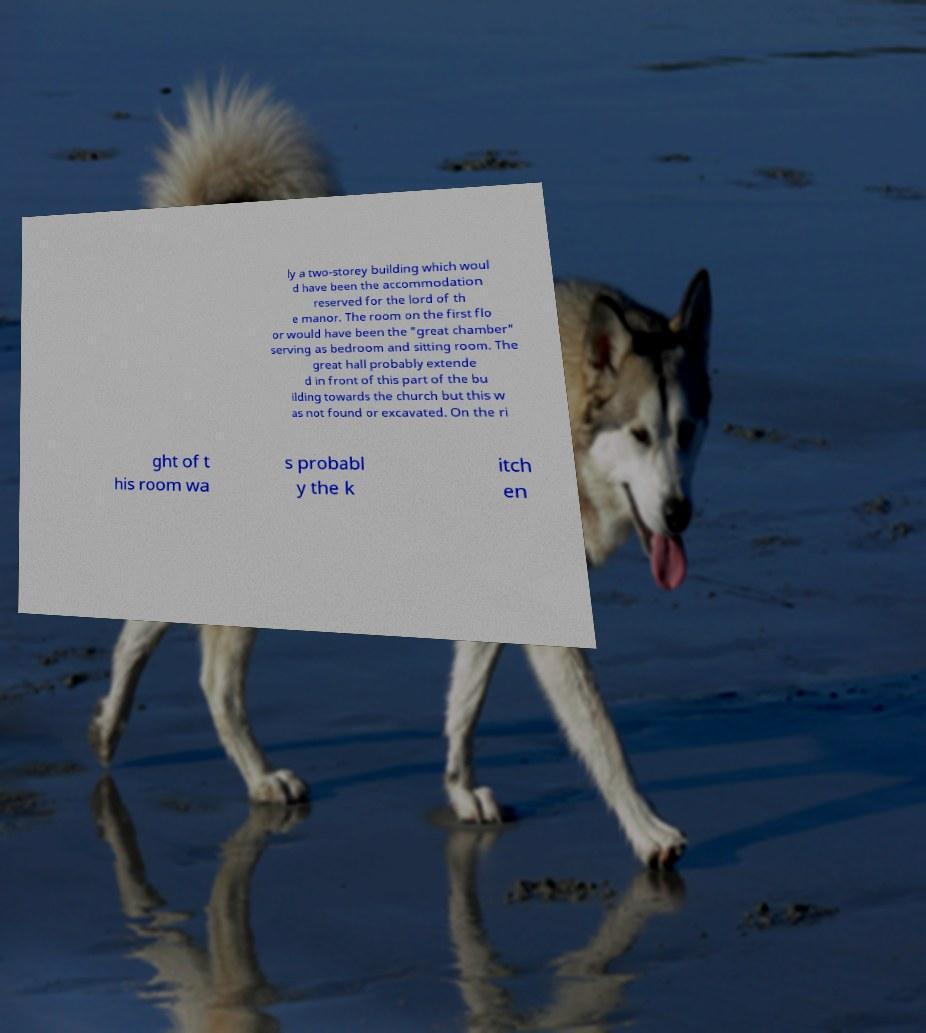There's text embedded in this image that I need extracted. Can you transcribe it verbatim? ly a two-storey building which woul d have been the accommodation reserved for the lord of th e manor. The room on the first flo or would have been the "great chamber" serving as bedroom and sitting room. The great hall probably extende d in front of this part of the bu ilding towards the church but this w as not found or excavated. On the ri ght of t his room wa s probabl y the k itch en 